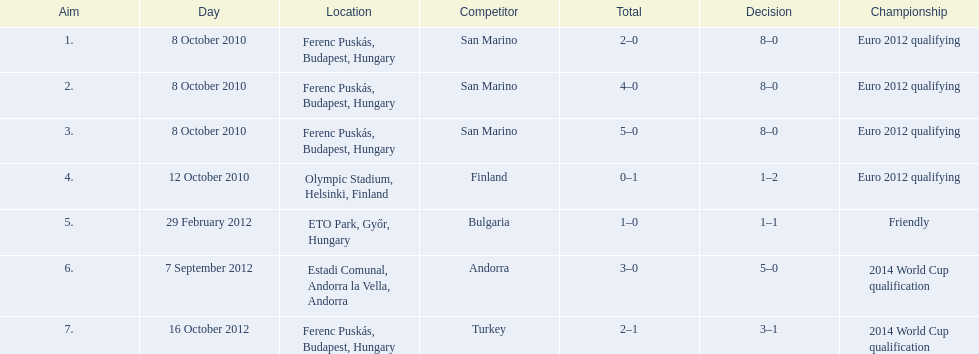How many non-qualifying games did he score in? 1. 